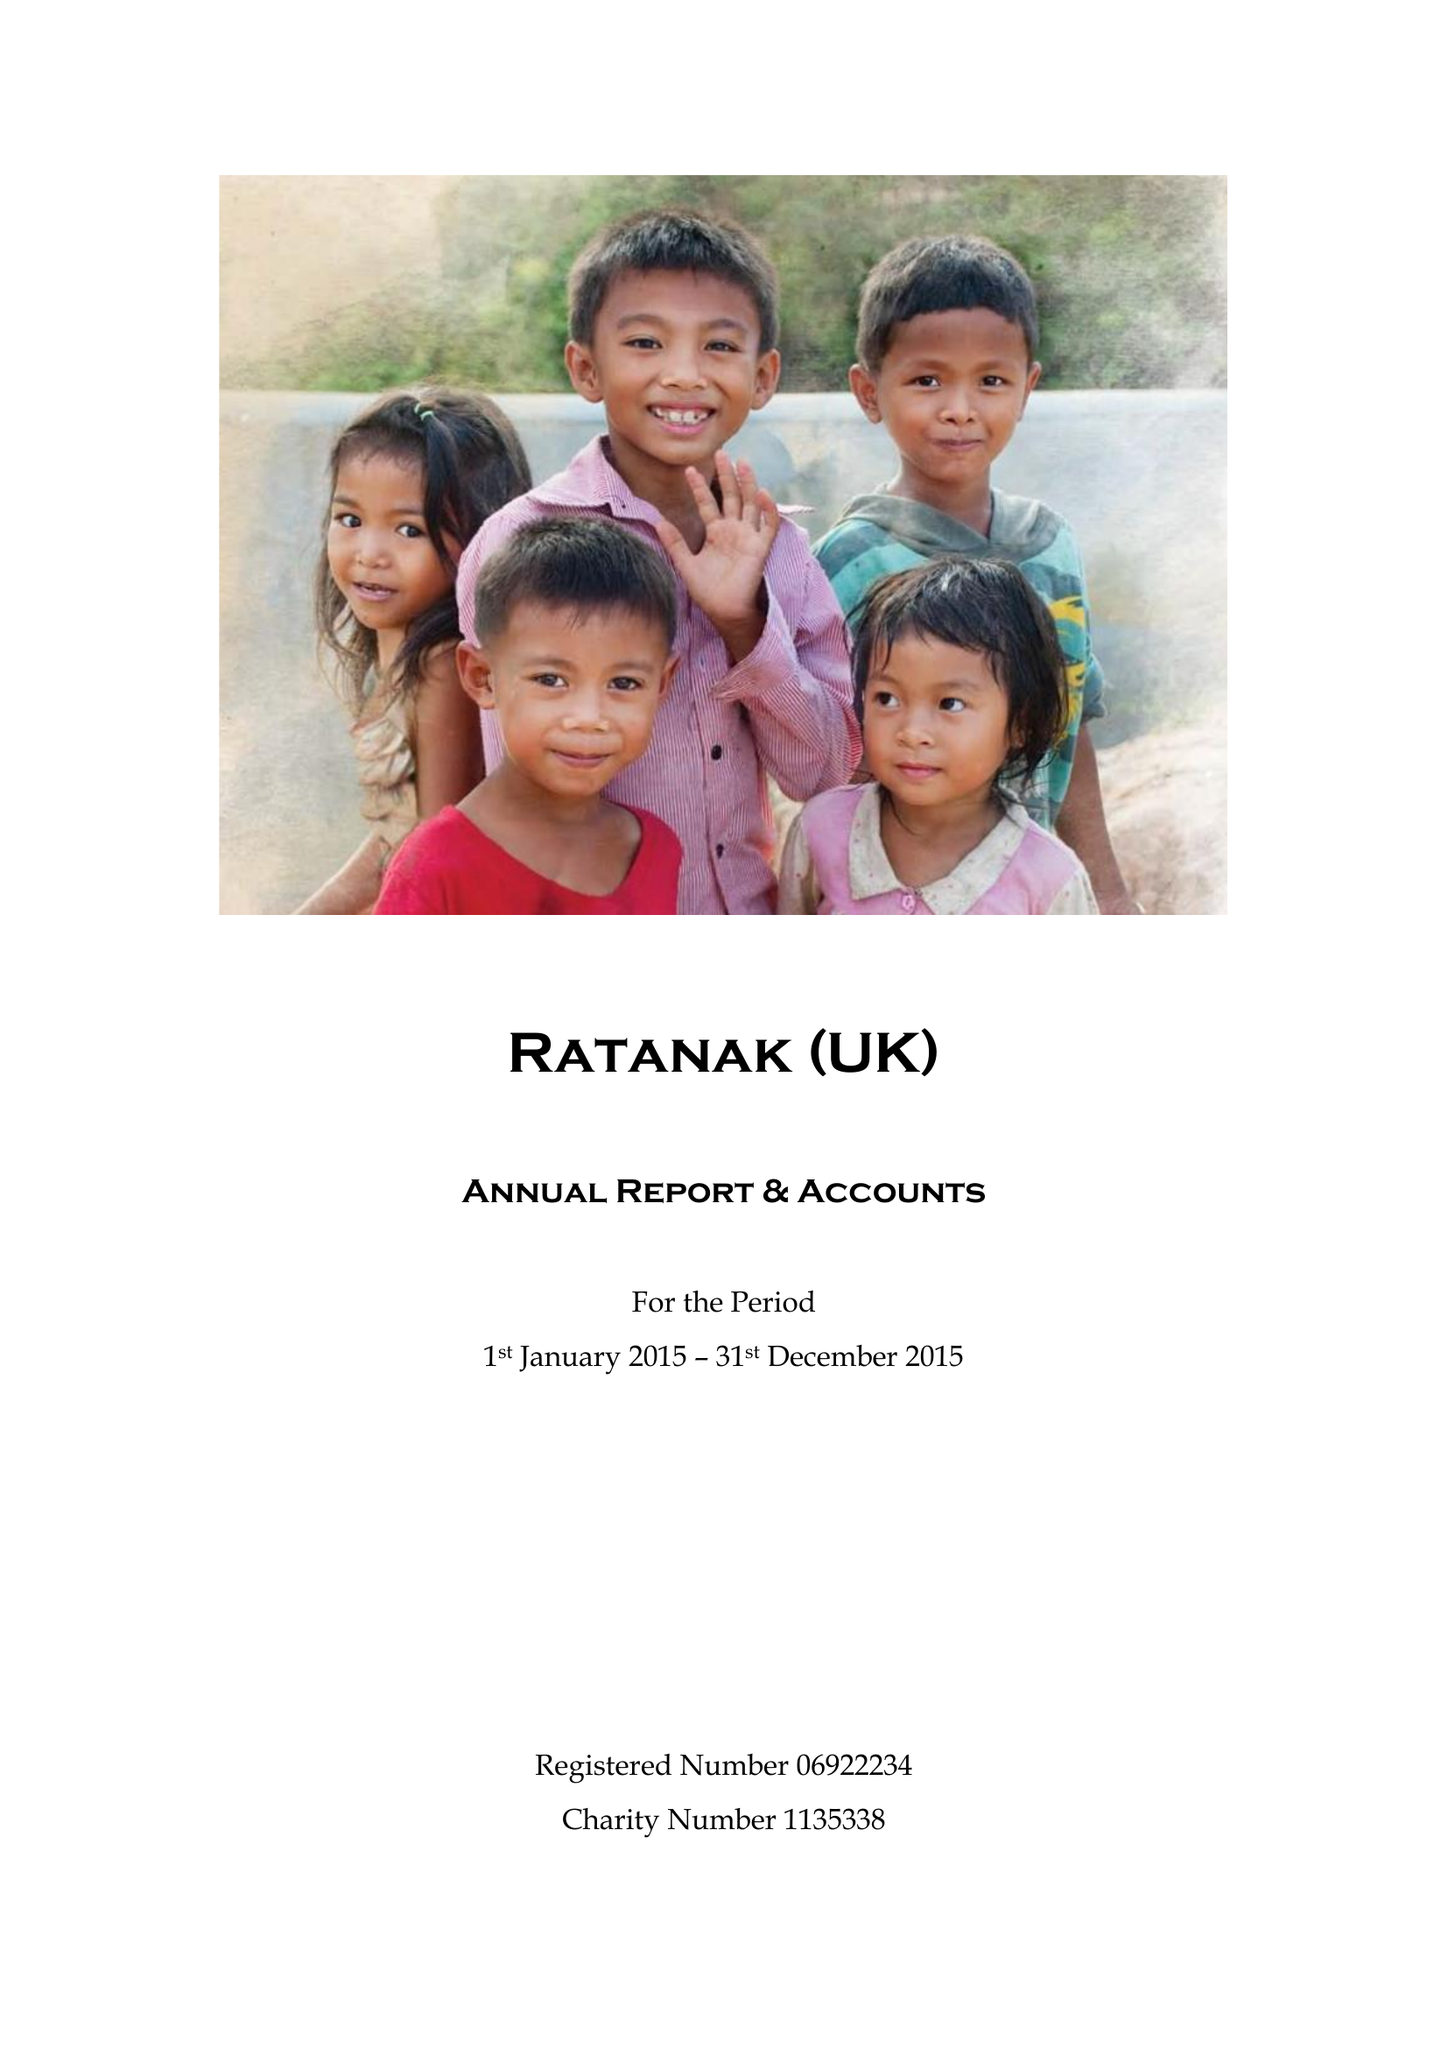What is the value for the spending_annually_in_british_pounds?
Answer the question using a single word or phrase. 59626.00 